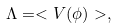Convert formula to latex. <formula><loc_0><loc_0><loc_500><loc_500>\Lambda = < V ( \phi ) > ,</formula> 